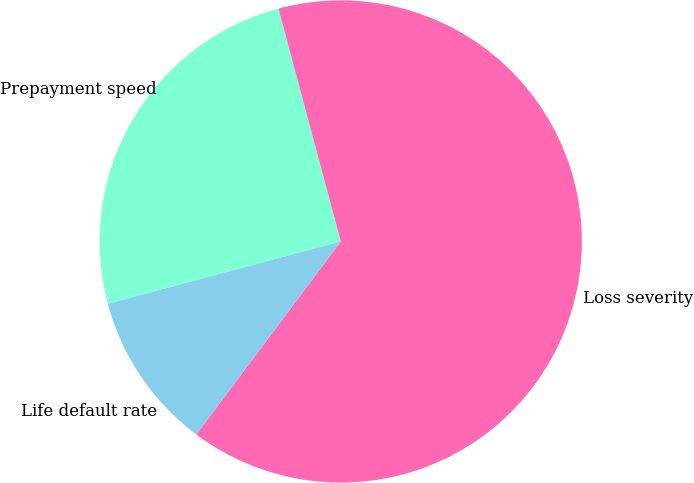Convert chart. <chart><loc_0><loc_0><loc_500><loc_500><pie_chart><fcel>Prepayment speed<fcel>Loss severity<fcel>Life default rate<nl><fcel>25.0%<fcel>64.39%<fcel>10.61%<nl></chart> 